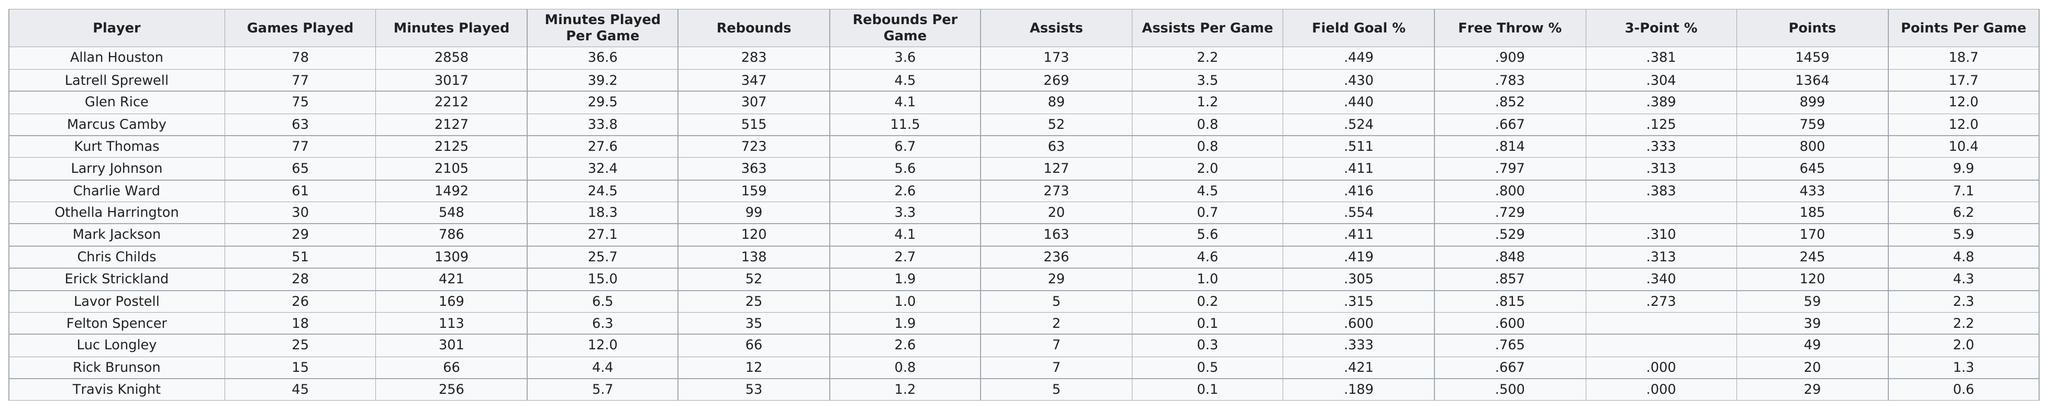Draw attention to some important aspects in this diagram. Just like Glen Rice, Marcus Camby averaged the same number of points per game, demonstrating his impressive scoring ability on the court. In the game where players averaged over 4 assists per game, a total of 848 points were scored. Charlie Ward was the player who had the most assists during the 2000-2001 season. In the battle of who scored more points, Larry Johnson emerged victorious, with a decisive lead over Charlie Ward. Four players had a field goal percentage greater than .500. 